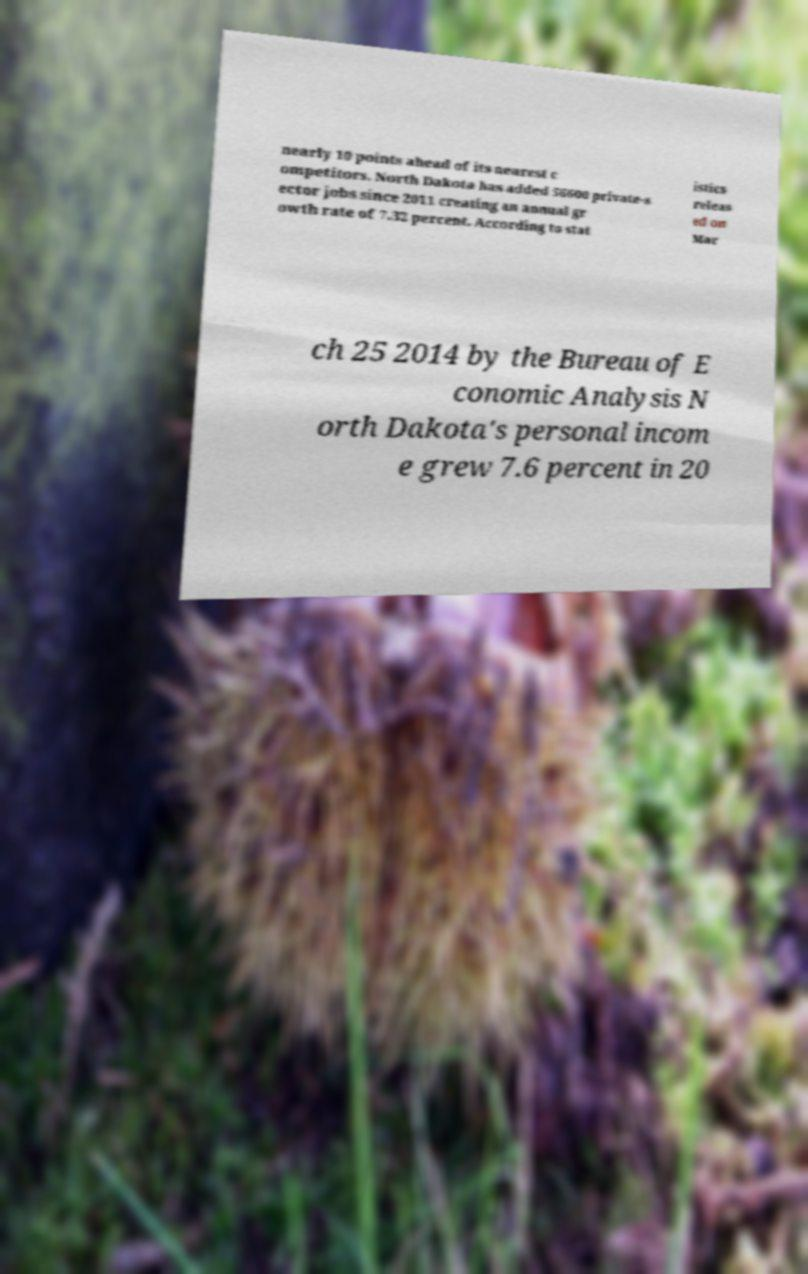Could you assist in decoding the text presented in this image and type it out clearly? nearly 10 points ahead of its nearest c ompetitors. North Dakota has added 56600 private-s ector jobs since 2011 creating an annual gr owth rate of 7.32 percent. According to stat istics releas ed on Mar ch 25 2014 by the Bureau of E conomic Analysis N orth Dakota's personal incom e grew 7.6 percent in 20 